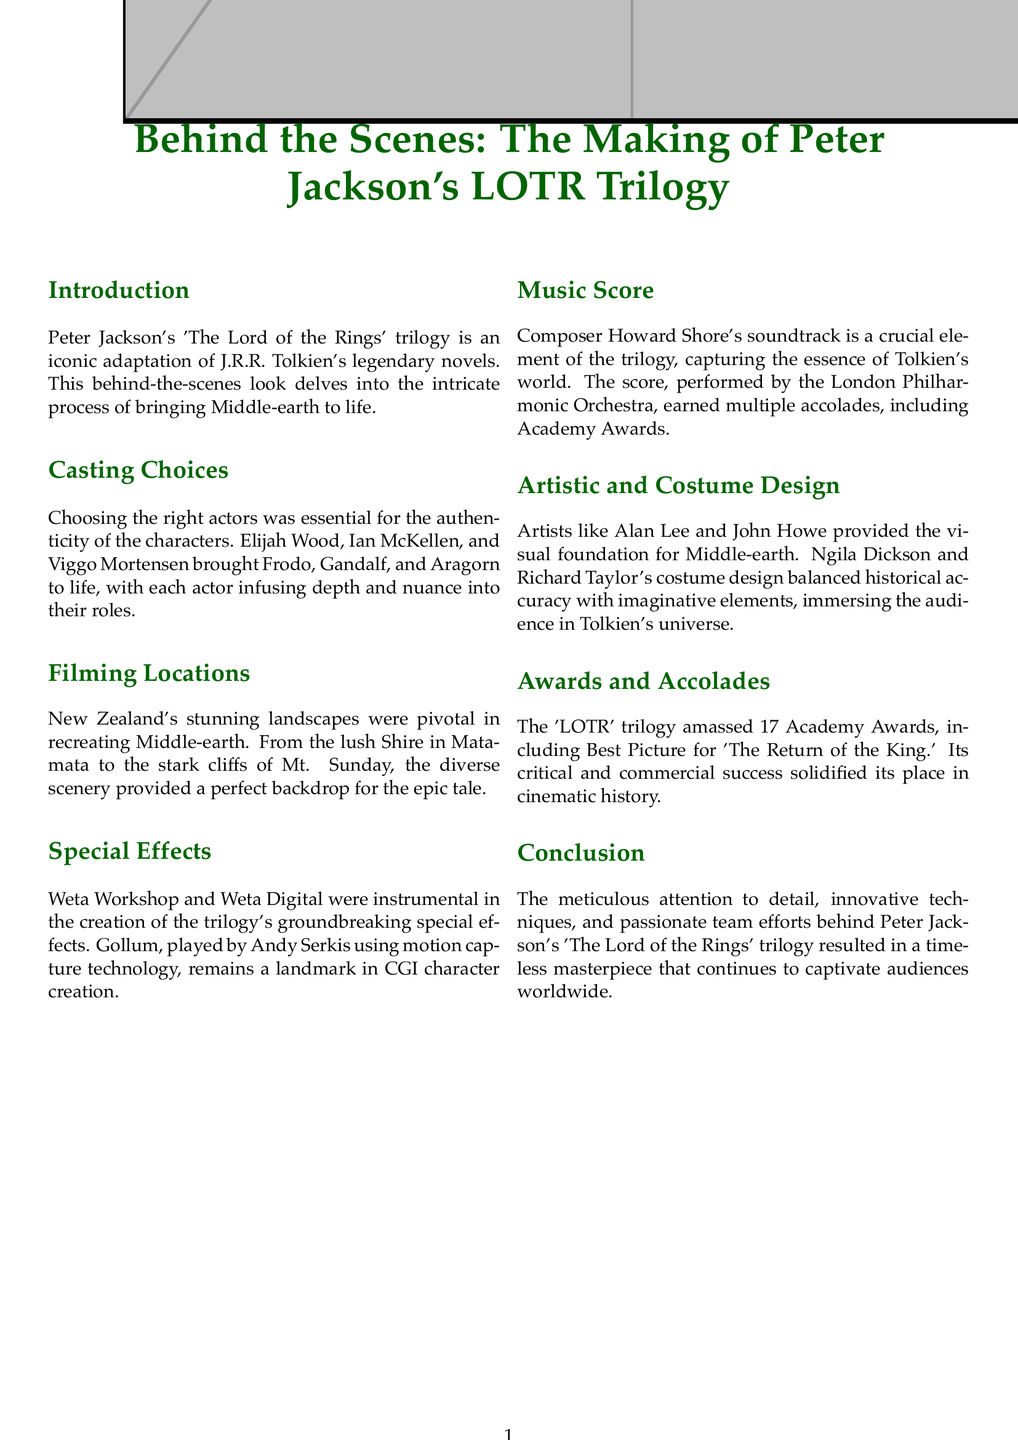What was the name of the trilogy? The name of the trilogy is stated in the title of the document.
Answer: The Lord of the Rings Who played Frodo? The document lists Elijah Wood as the actor who portrayed Frodo.
Answer: Elijah Wood Which awards did the trilogy win? The section on awards mentions the total number of Academy Awards won by the trilogy.
Answer: 17 Academy Awards What technology was used to create Gollum? The document highlights the use of motion capture technology for Gollum.
Answer: Motion capture technology Who composed the score for the trilogy? The document specifies that Howard Shore was the composer of the soundtrack.
Answer: Howard Shore What location represented the Shire? The document identifies Matamata as the location for the Shire.
Answer: Matamata What element is crucial to conveying Tolkien’s essence? The document mentions that the music score captures the essence of Tolkien's world.
Answer: Music Score Which artist provided the visual foundation for Middle-earth? The document names Alan Lee and John Howe as the contributing artists.
Answer: Alan Lee and John Howe How many films are in the trilogy? The title and context imply a specific number of films, pertinent to the trilogy described.
Answer: Three films 